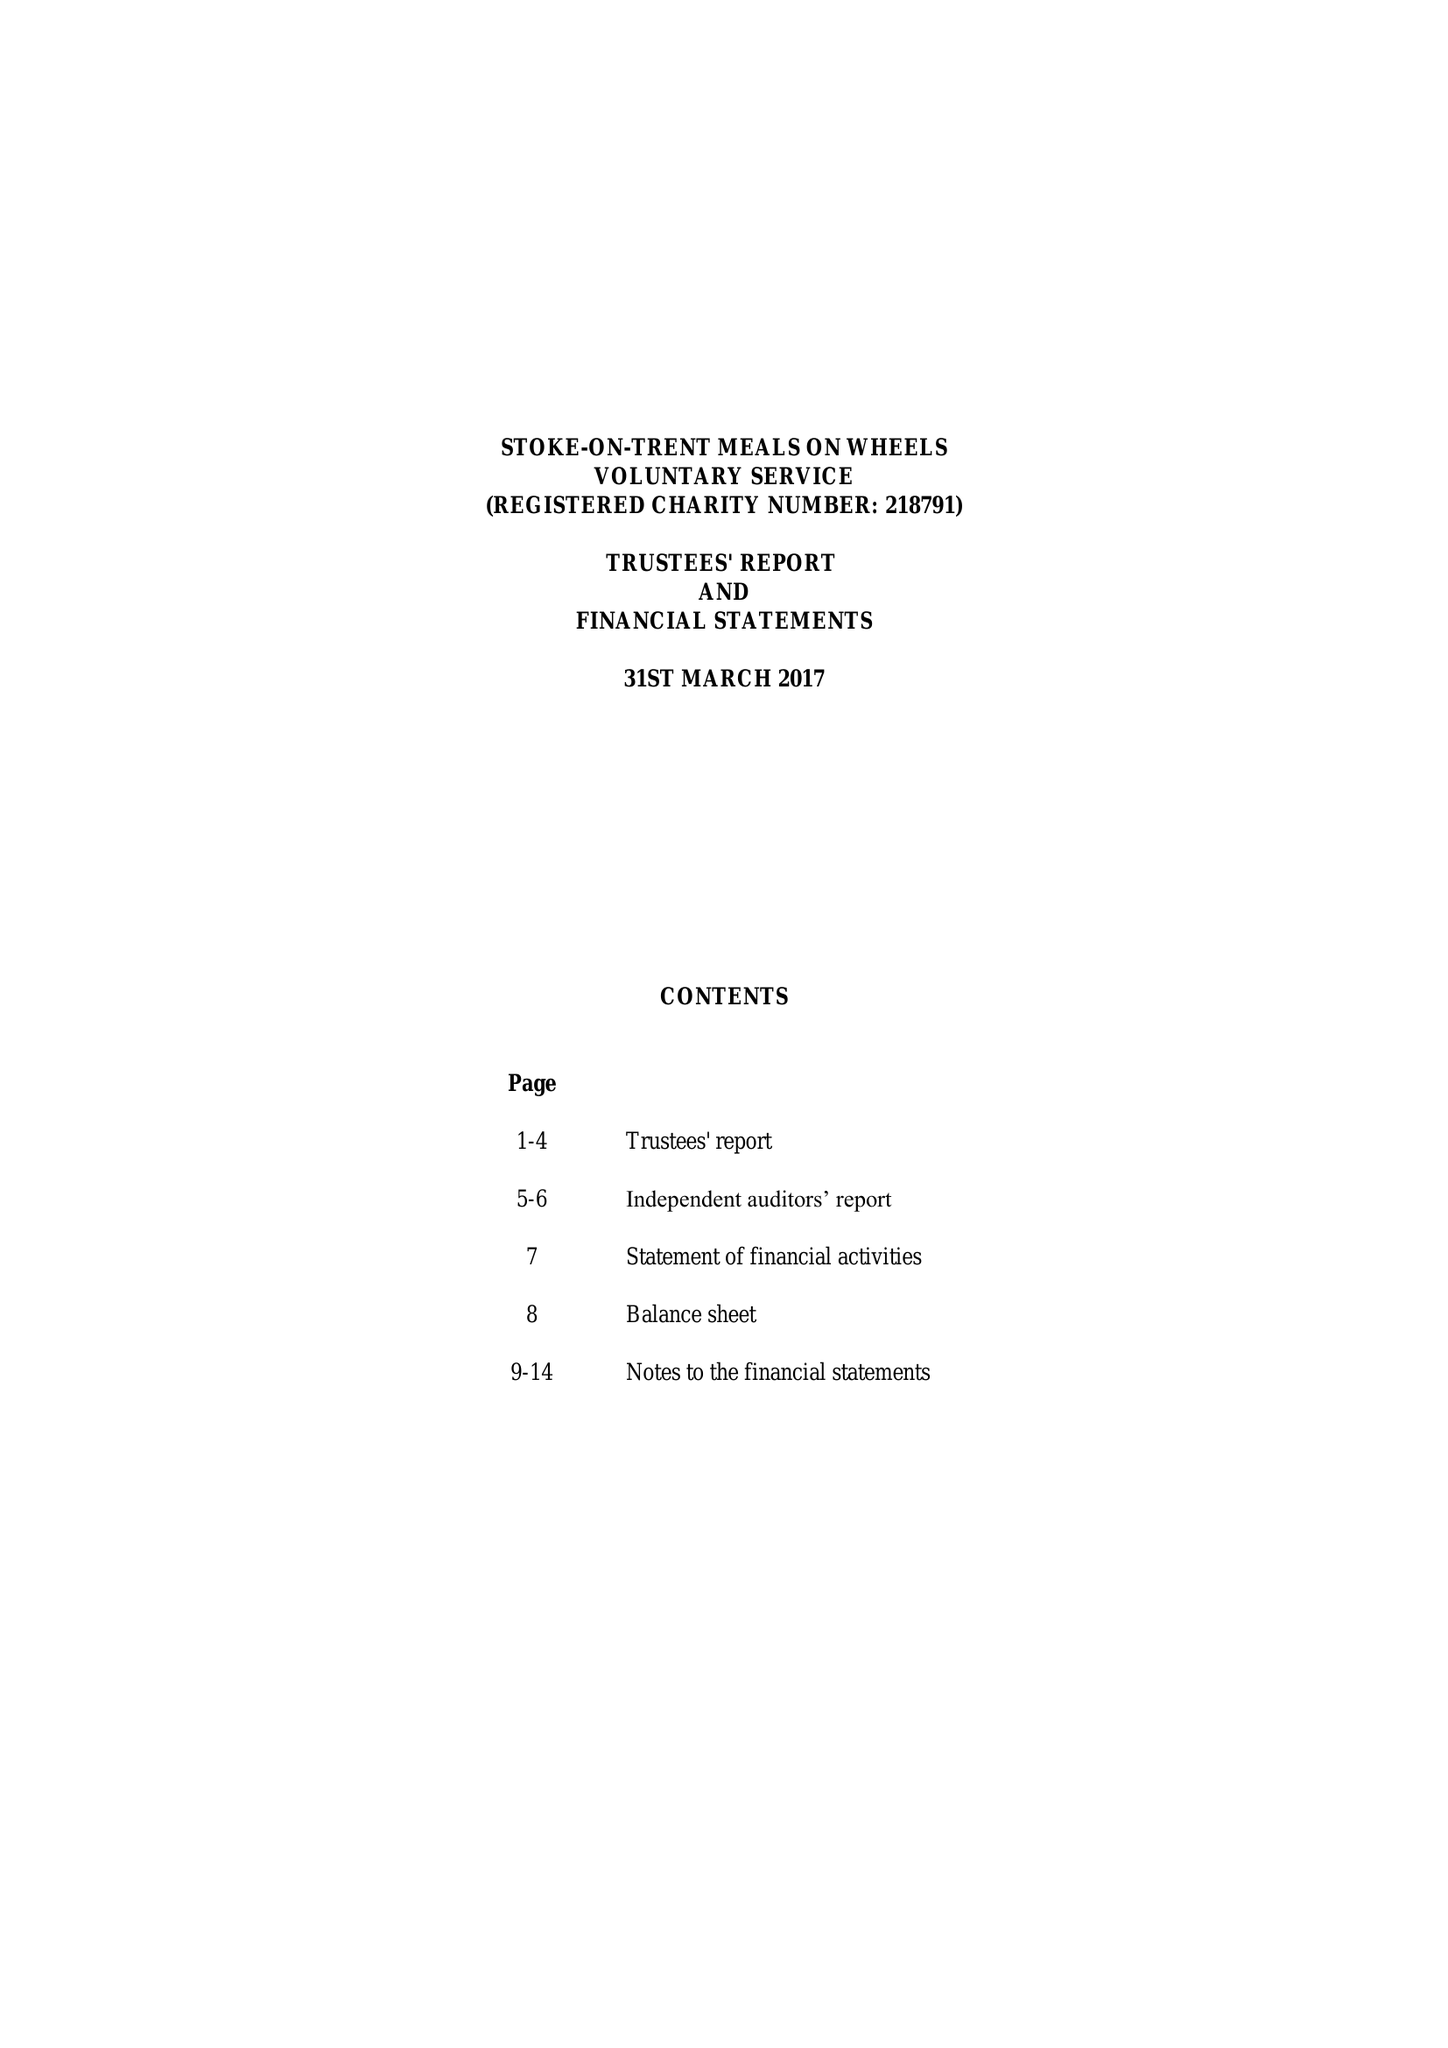What is the value for the charity_name?
Answer the question using a single word or phrase. Meals On Wheels (Stoke On Trent) 